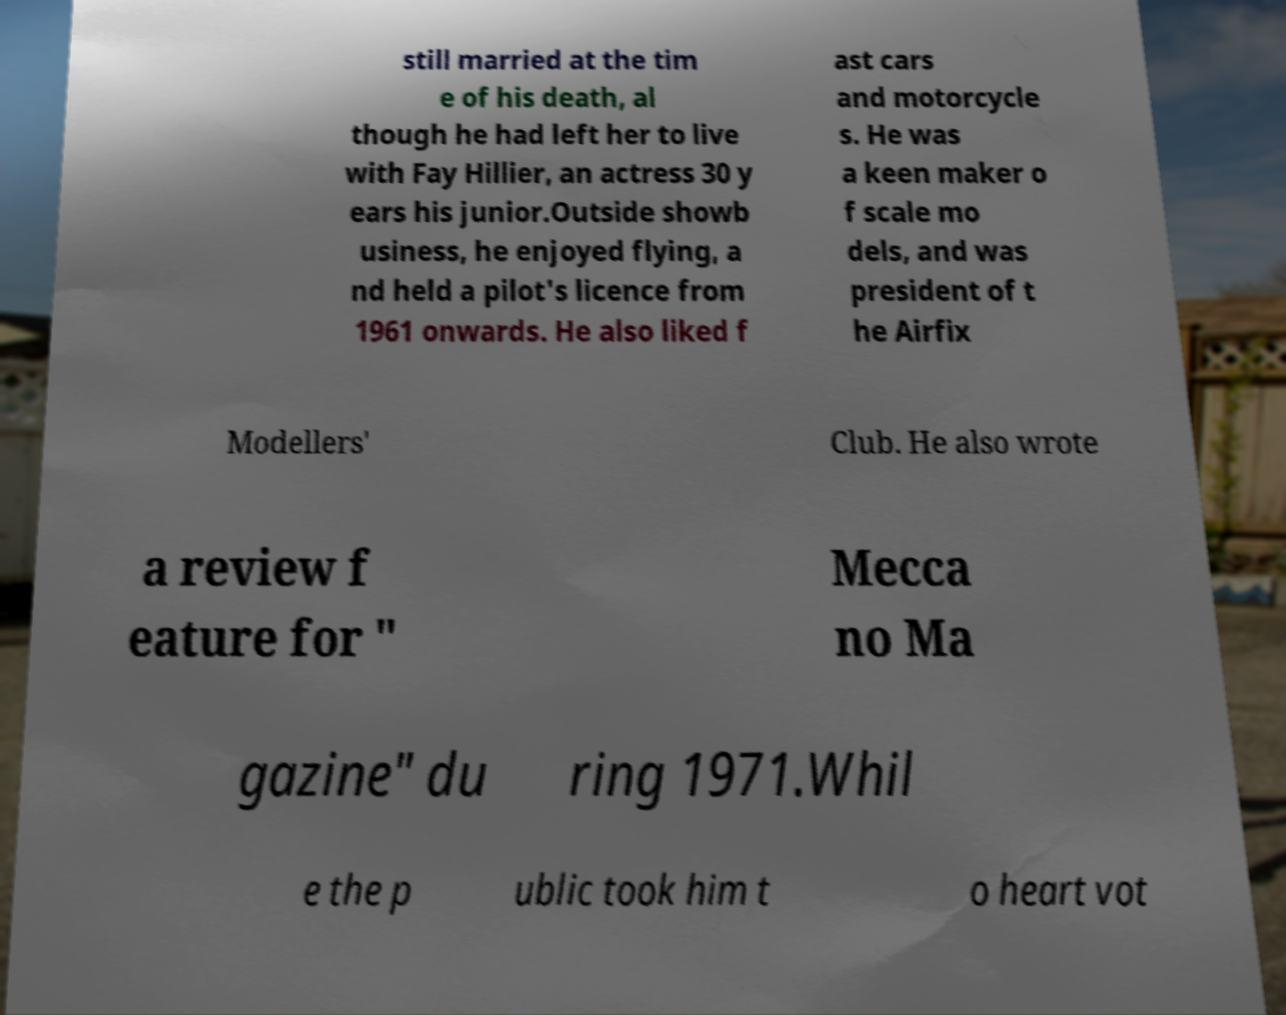For documentation purposes, I need the text within this image transcribed. Could you provide that? still married at the tim e of his death, al though he had left her to live with Fay Hillier, an actress 30 y ears his junior.Outside showb usiness, he enjoyed flying, a nd held a pilot's licence from 1961 onwards. He also liked f ast cars and motorcycle s. He was a keen maker o f scale mo dels, and was president of t he Airfix Modellers' Club. He also wrote a review f eature for " Mecca no Ma gazine" du ring 1971.Whil e the p ublic took him t o heart vot 